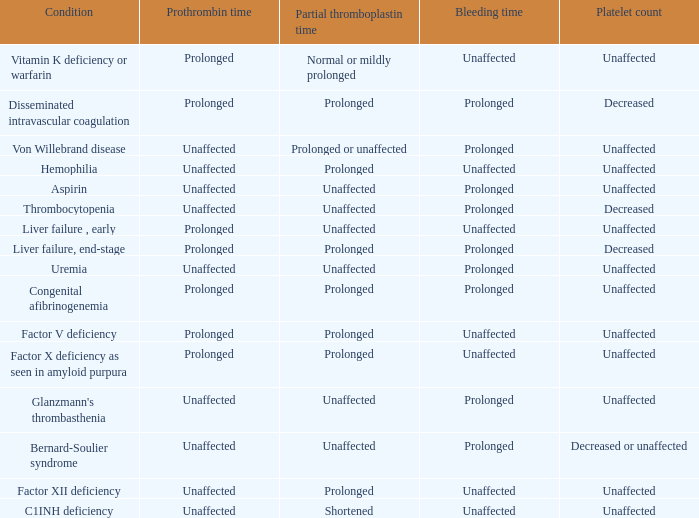Which disorder does not impact partial thromboplastin time, platelet count, and prothrombin time? Aspirin, Uremia, Glanzmann's thrombasthenia. 